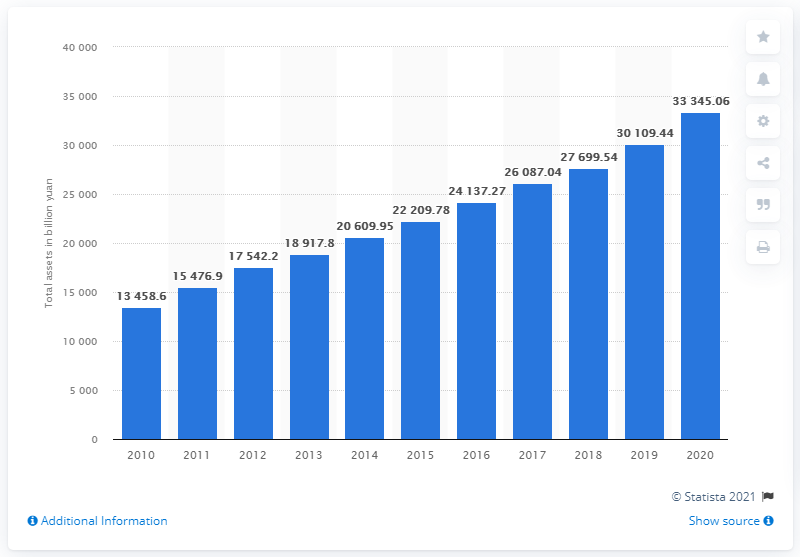Give some essential details in this illustration. The total assets of the Industrial and Commercial Bank of China in 2020 were approximately 333,450.60. 